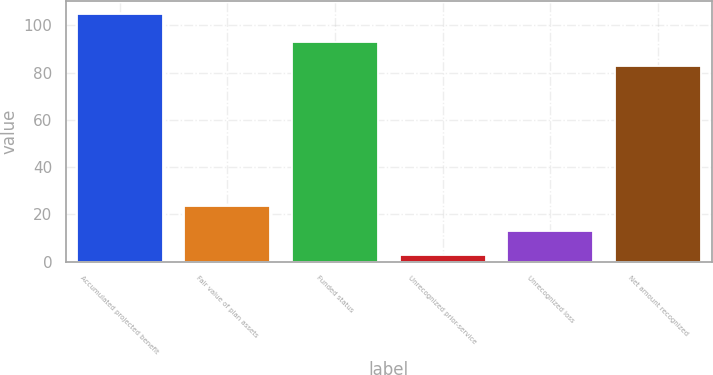<chart> <loc_0><loc_0><loc_500><loc_500><bar_chart><fcel>Accumulated projected benefit<fcel>Fair value of plan assets<fcel>Funded status<fcel>Unrecognized prior-service<fcel>Unrecognized loss<fcel>Net amount recognized<nl><fcel>105<fcel>23.4<fcel>93.2<fcel>3<fcel>13.2<fcel>83<nl></chart> 